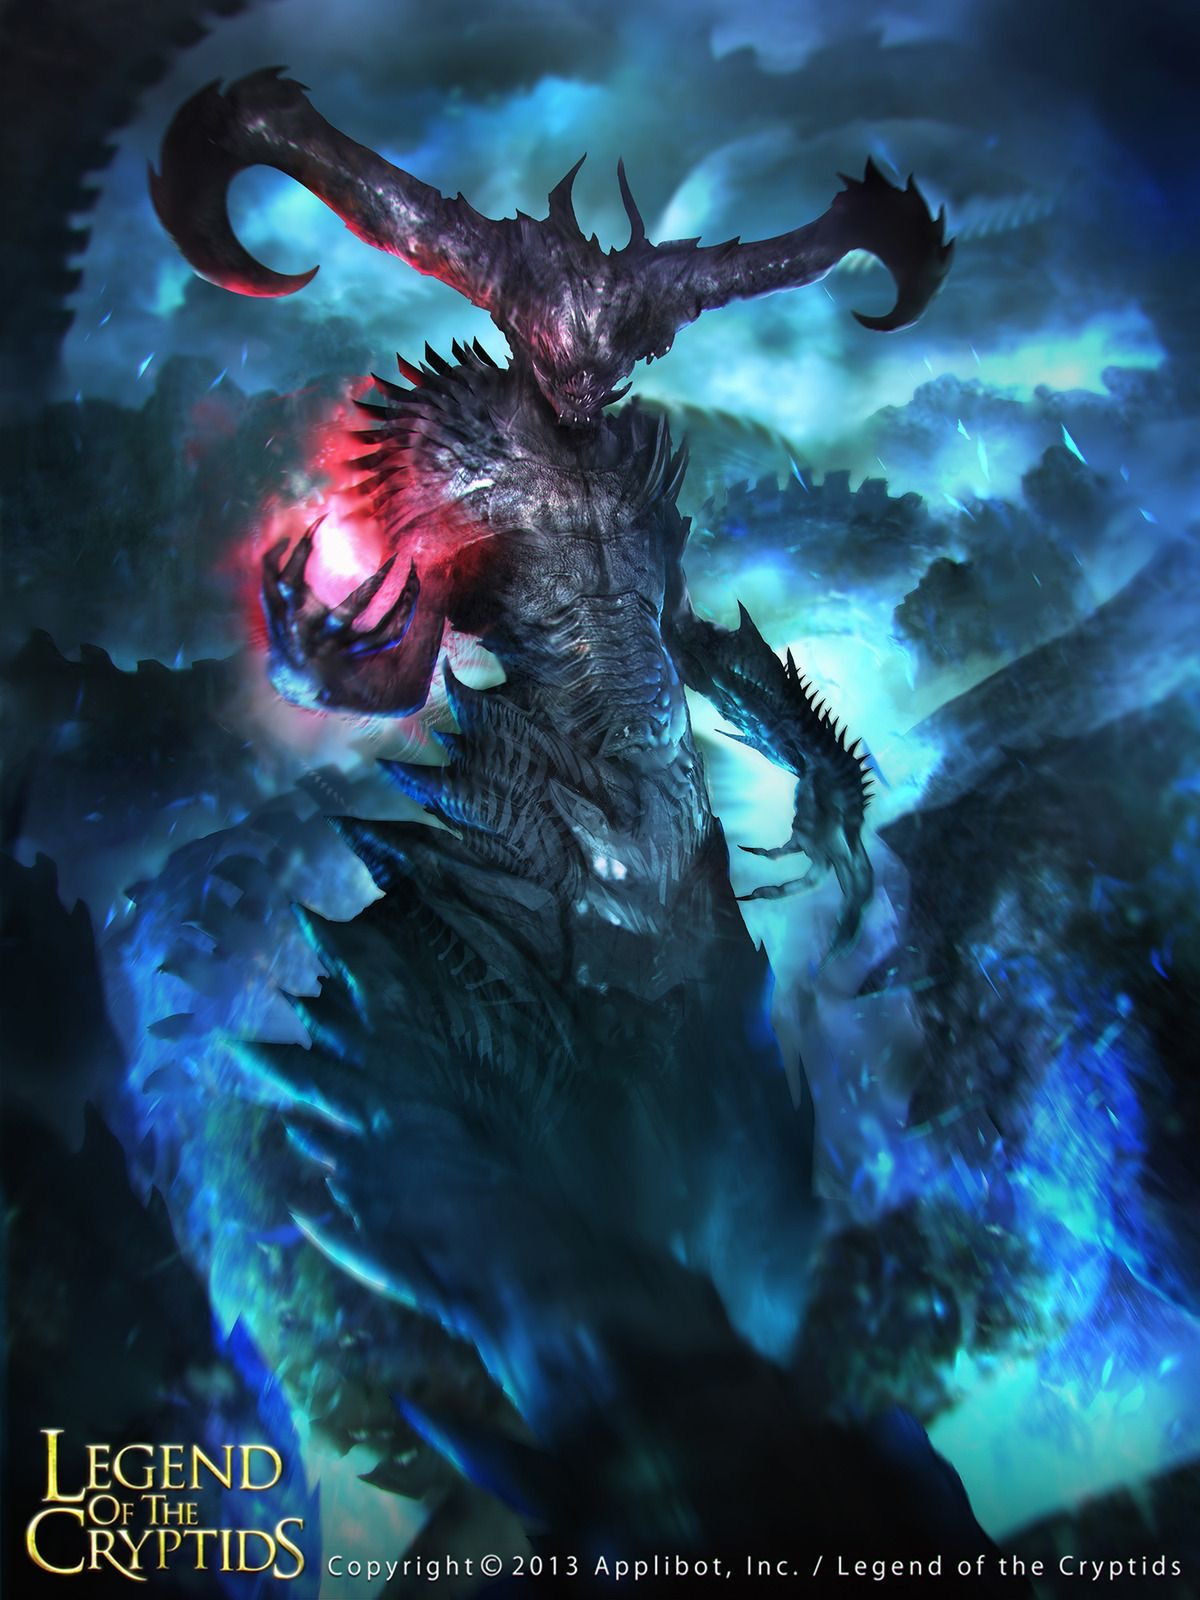Come up with a description for the content of this image (make it {extreme knowledge}, no more than 9 words!), while also describing the style of this image in detail. For the latter, look at the texture carefully to determine the techniqe used. Be specific. In that part, mention the style and exact content. Briefly describe the style as aptly as possible, don't say 'likely', make an straight forward response, giving great emphasis on the techniques used to generate such an image (dark fantasy artwork, for example, or max knowledge detail/ every exact even small details in the image), including details about how sparse/minimal or complex it is. Then provide your response in the following format, always using a | to separate the new content idea from the style descriptions: <content in the image>, | <details>, <small details>, <exact look and feel>, <colors used>. You will be inclined to say 'digital' if you're not sure, please only do that when you're certain, and go into full detail first. Demonic creature wielding energy orb in a mystical realm | Highly detailed dark fantasy digital artwork, featuring a horned demonic creature with jagged armor, glowing red and blue energy, surrounded by an ethereal, stormy background, sharp textures, intricate shadows, vibrant contrasts, and deep hues of black, blue, and red. Come up with a description for the content of this image (make it {extreme knowledge}!), while also describing the style of this image in detail. For the latter, look at the texture carefully to determine the techniqe used. Be specific. In that part, mention the style and exact content. Briefly describe the style as aptly as possible, don't say 'likely', make an straight forward response, giving great emphasis on the techniques used to generate such an image (dark fantasy artwork, for example, or max knowledge detail/ every exact even small details in the image), including details about how sparse/minimal or complex it is. Then provide your response in the following format, always using a | to separate the new content idea from the style descriptions: <content in the image>, | <details>, <small details>, <exact look and feel>, <colors used>. You will be inclined to say 'digital' if you're not sure, please only do that when you're certain, and go into full detail first. Demonic entity conjuring a glowing energy sphere | Intricate dark fantasy digital artwork, featuring a horned demon with jagged, blackened armor, emanating a mix of red and blue energy light, set against a turbulent, otherworldly backdrop, sharp and detailed textures, layered shadows, and vivid contrasts, deep blacks, glowing reds, and luminescent blues. 